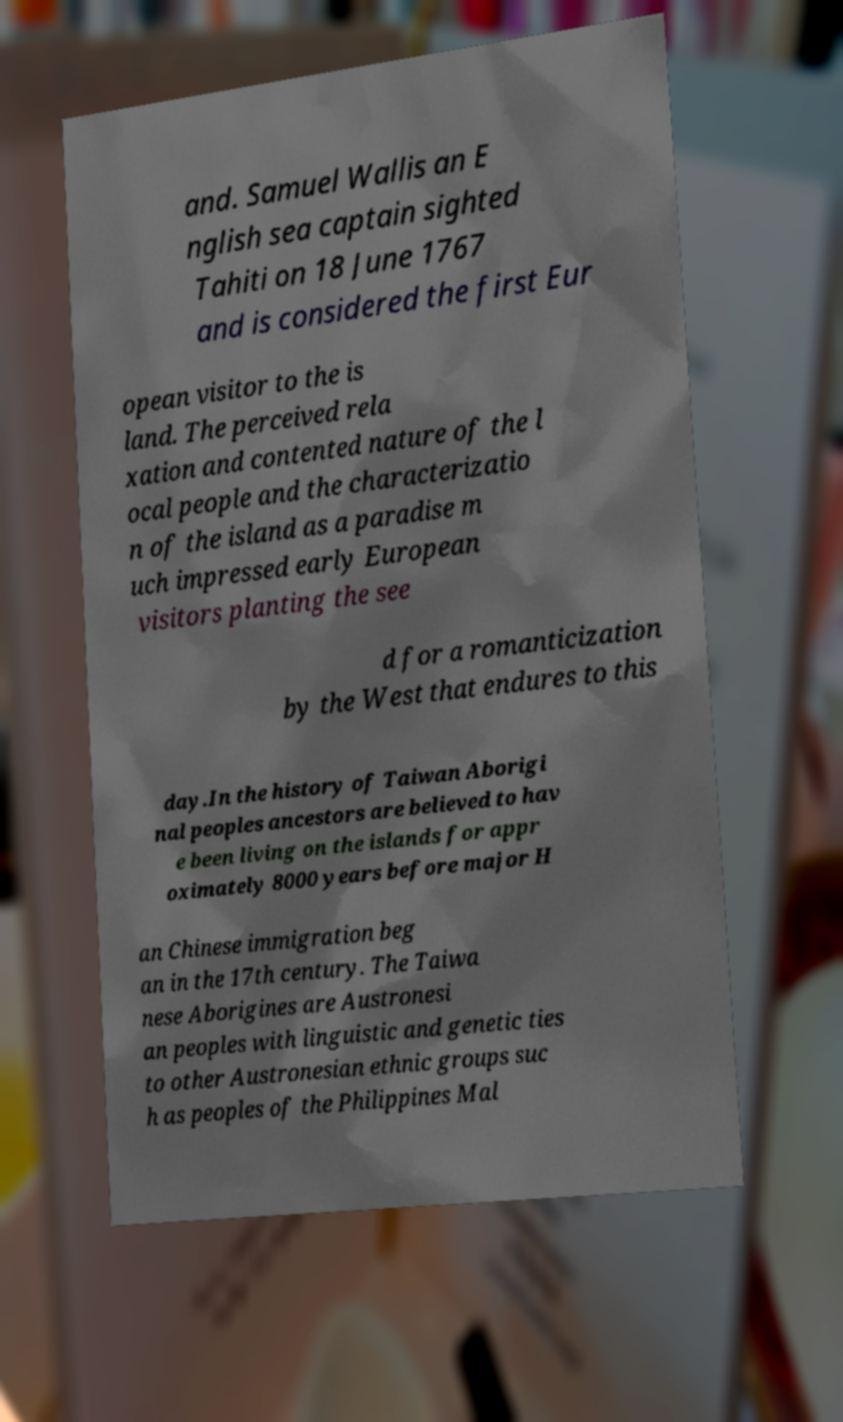There's text embedded in this image that I need extracted. Can you transcribe it verbatim? and. Samuel Wallis an E nglish sea captain sighted Tahiti on 18 June 1767 and is considered the first Eur opean visitor to the is land. The perceived rela xation and contented nature of the l ocal people and the characterizatio n of the island as a paradise m uch impressed early European visitors planting the see d for a romanticization by the West that endures to this day.In the history of Taiwan Aborigi nal peoples ancestors are believed to hav e been living on the islands for appr oximately 8000 years before major H an Chinese immigration beg an in the 17th century. The Taiwa nese Aborigines are Austronesi an peoples with linguistic and genetic ties to other Austronesian ethnic groups suc h as peoples of the Philippines Mal 